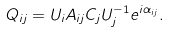<formula> <loc_0><loc_0><loc_500><loc_500>Q _ { i j } = U _ { i } A _ { i j } C _ { j } U ^ { - 1 } _ { j } e ^ { i \alpha _ { i j } } .</formula> 